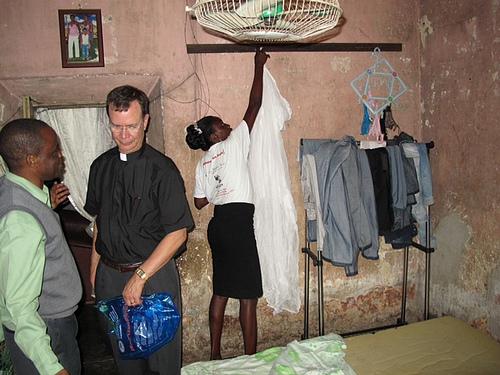<image>
Is there a pants on the man? No. The pants is not positioned on the man. They may be near each other, but the pants is not supported by or resting on top of the man. Is there a lady under the fan? Yes. The lady is positioned underneath the fan, with the fan above it in the vertical space. Is there a woman to the left of the man? Yes. From this viewpoint, the woman is positioned to the left side relative to the man. Is the woman in front of the man? Yes. The woman is positioned in front of the man, appearing closer to the camera viewpoint. 